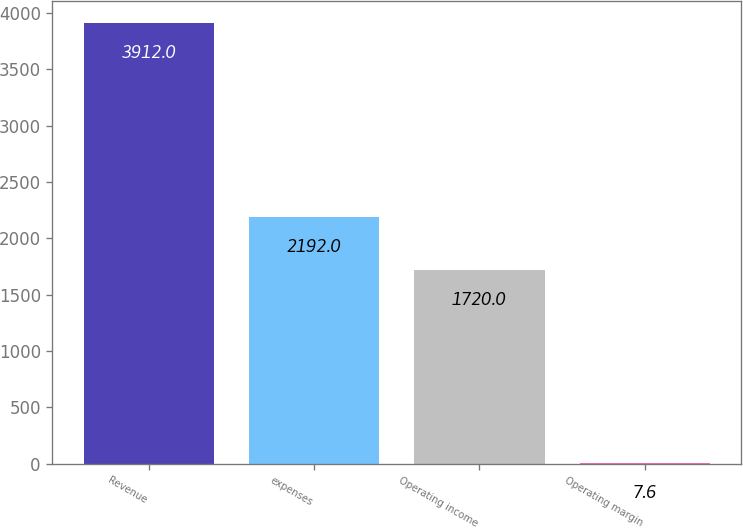<chart> <loc_0><loc_0><loc_500><loc_500><bar_chart><fcel>Revenue<fcel>expenses<fcel>Operating income<fcel>Operating margin<nl><fcel>3912<fcel>2192<fcel>1720<fcel>7.6<nl></chart> 